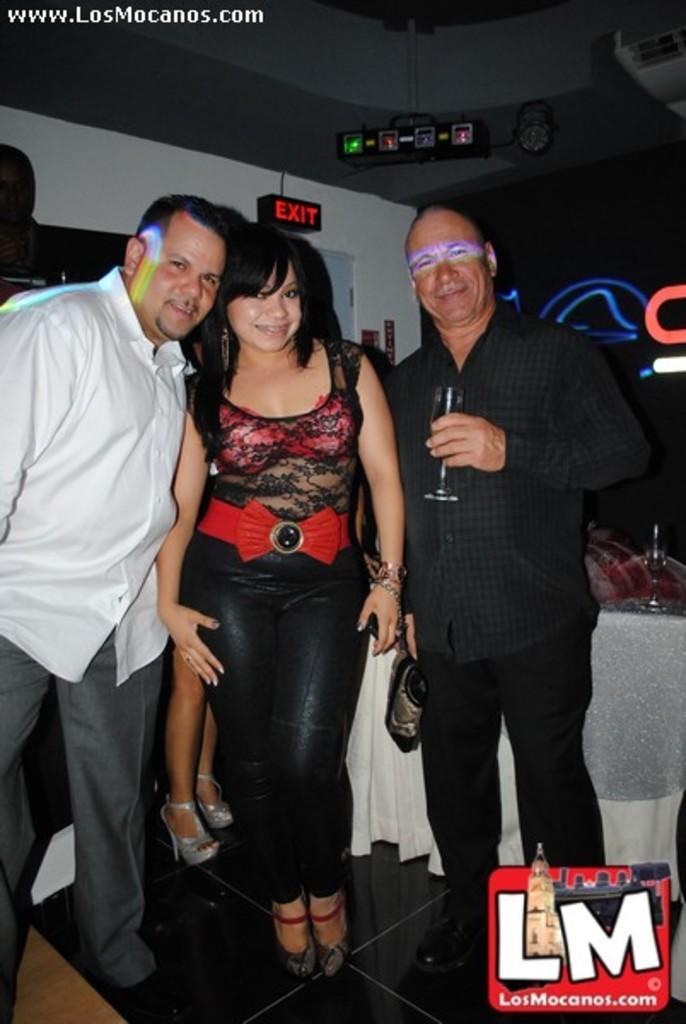Describe this image in one or two sentences. In this picture we can see two men and one woman in the middle, standing and giving a pose to the camera. Behind there is a screen, sports lights and white wall. On the front bottom side we can see the watermark. 